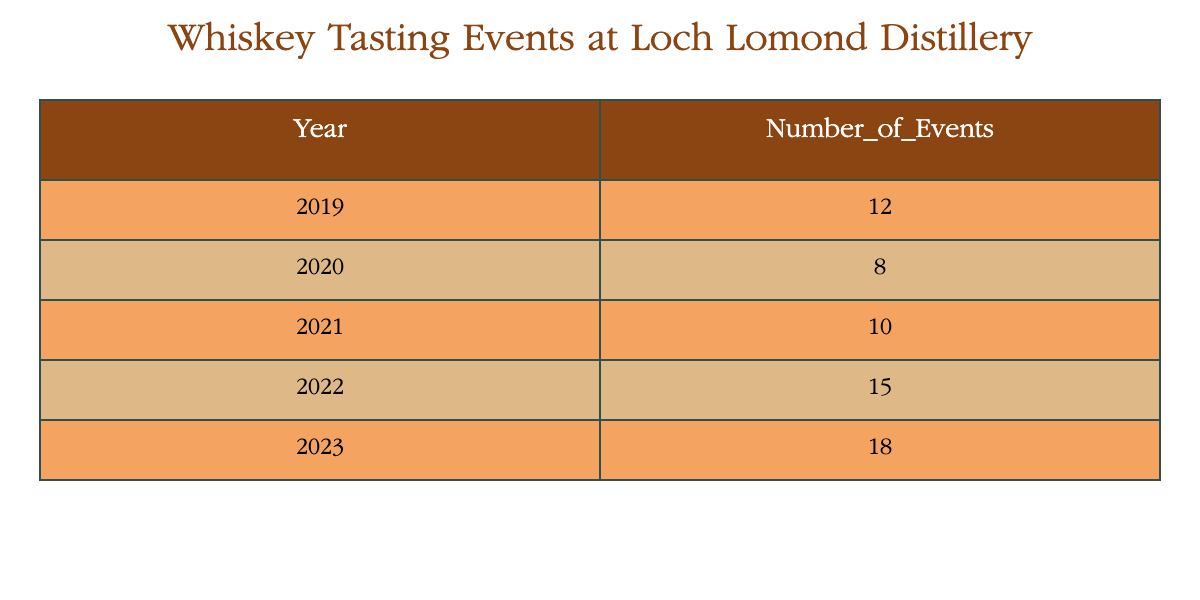What year had the highest number of whiskey tasting events? Looking at the table, the year 2023 has the highest number of events, which is 18.
Answer: 2023 How many whiskey tasting events were hosted in 2020? The table indicates that in the year 2020, there were 8 whiskey tasting events hosted.
Answer: 8 What was the total number of tasting events held across all five years? To find the total, we add the number of events: 12 + 8 + 10 + 15 + 18 = 63.
Answer: 63 Which year saw an increase in the number of events compared to the previous year? From the table, we see that 2022 had 15 events compared to 2021's 10 events, indicating an increase. Likewise, 2023 with 18 events compared to 2022's 15 also shows an increase.
Answer: 2022 and 2023 Was there a year when fewer than 10 events were held? Yes, the year 2020 saw only 8 tasting events, which is fewer than 10.
Answer: Yes What is the average number of whiskey tasting events per year over the five-year period? To find the average, we take the total number of events (63) and divide it by the number of years (5): 63 / 5 = 12.6.
Answer: 12.6 In which year did the events increase the most compared to the previous year? Comparing the events year-over-year: 2020 (8 to 10), 2021 (10 to 15) shows an increase of 5, while 2022 (15 to 18) shows an increase of 3. The largest increase was from 2021 to 2022.
Answer: 2021 to 2022 How many more events were held in 2023 compared to 2019? The difference in events between 2023 (18) and 2019 (12) is calculated by subtracting: 18 - 12 = 6.
Answer: 6 Did the number of events ever decrease from one year to the next? No, the table indicates that the number of events either increased or remained the same each year with no decreases observed.
Answer: No 